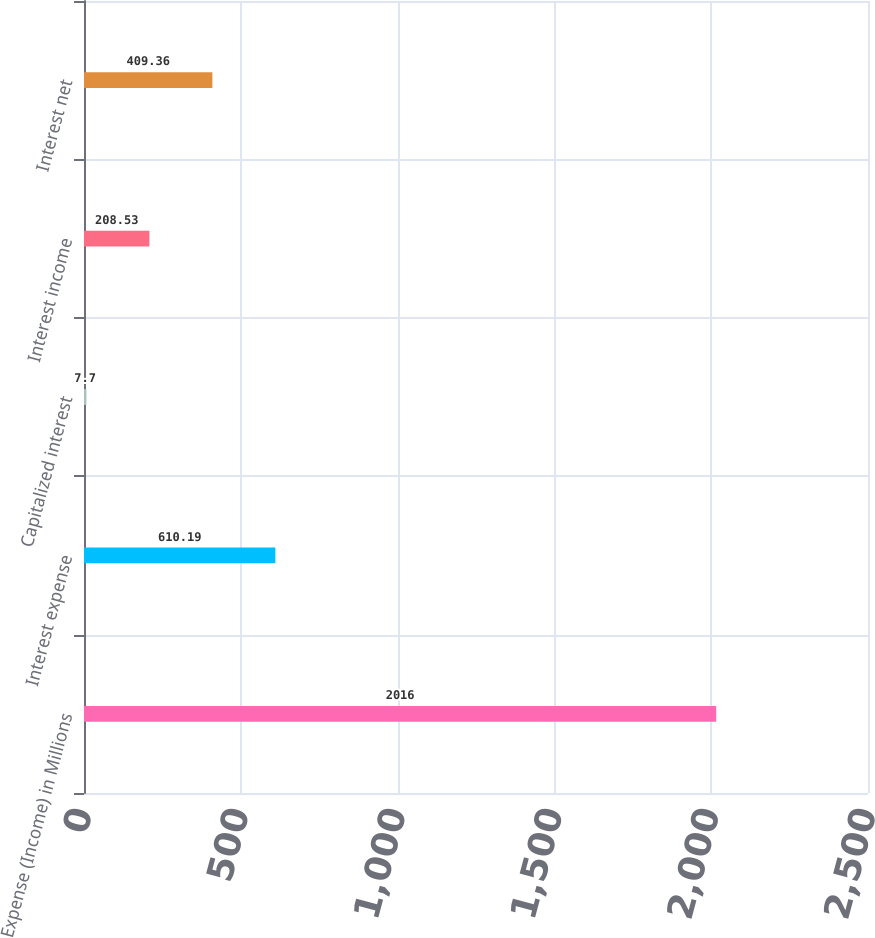<chart> <loc_0><loc_0><loc_500><loc_500><bar_chart><fcel>Expense (Income) in Millions<fcel>Interest expense<fcel>Capitalized interest<fcel>Interest income<fcel>Interest net<nl><fcel>2016<fcel>610.19<fcel>7.7<fcel>208.53<fcel>409.36<nl></chart> 